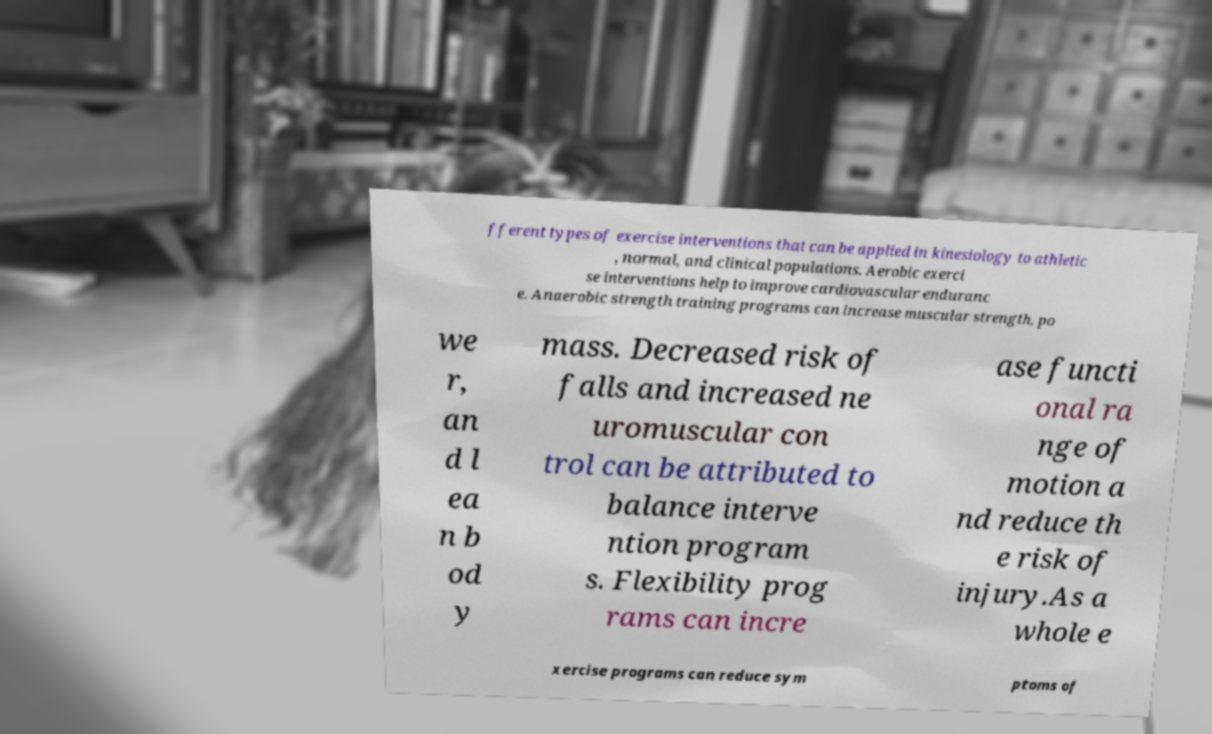What messages or text are displayed in this image? I need them in a readable, typed format. fferent types of exercise interventions that can be applied in kinesiology to athletic , normal, and clinical populations. Aerobic exerci se interventions help to improve cardiovascular enduranc e. Anaerobic strength training programs can increase muscular strength, po we r, an d l ea n b od y mass. Decreased risk of falls and increased ne uromuscular con trol can be attributed to balance interve ntion program s. Flexibility prog rams can incre ase functi onal ra nge of motion a nd reduce th e risk of injury.As a whole e xercise programs can reduce sym ptoms of 